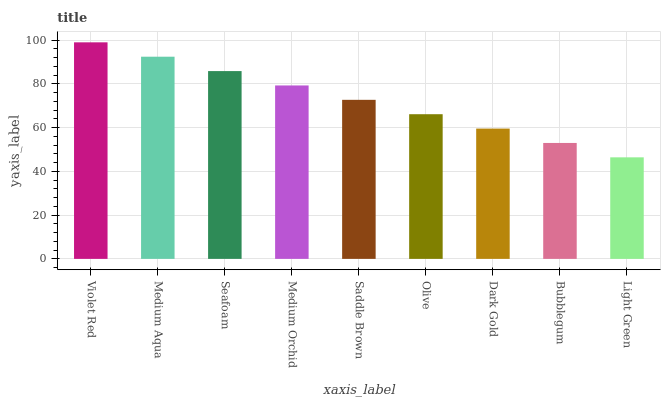Is Medium Aqua the minimum?
Answer yes or no. No. Is Medium Aqua the maximum?
Answer yes or no. No. Is Violet Red greater than Medium Aqua?
Answer yes or no. Yes. Is Medium Aqua less than Violet Red?
Answer yes or no. Yes. Is Medium Aqua greater than Violet Red?
Answer yes or no. No. Is Violet Red less than Medium Aqua?
Answer yes or no. No. Is Saddle Brown the high median?
Answer yes or no. Yes. Is Saddle Brown the low median?
Answer yes or no. Yes. Is Violet Red the high median?
Answer yes or no. No. Is Olive the low median?
Answer yes or no. No. 